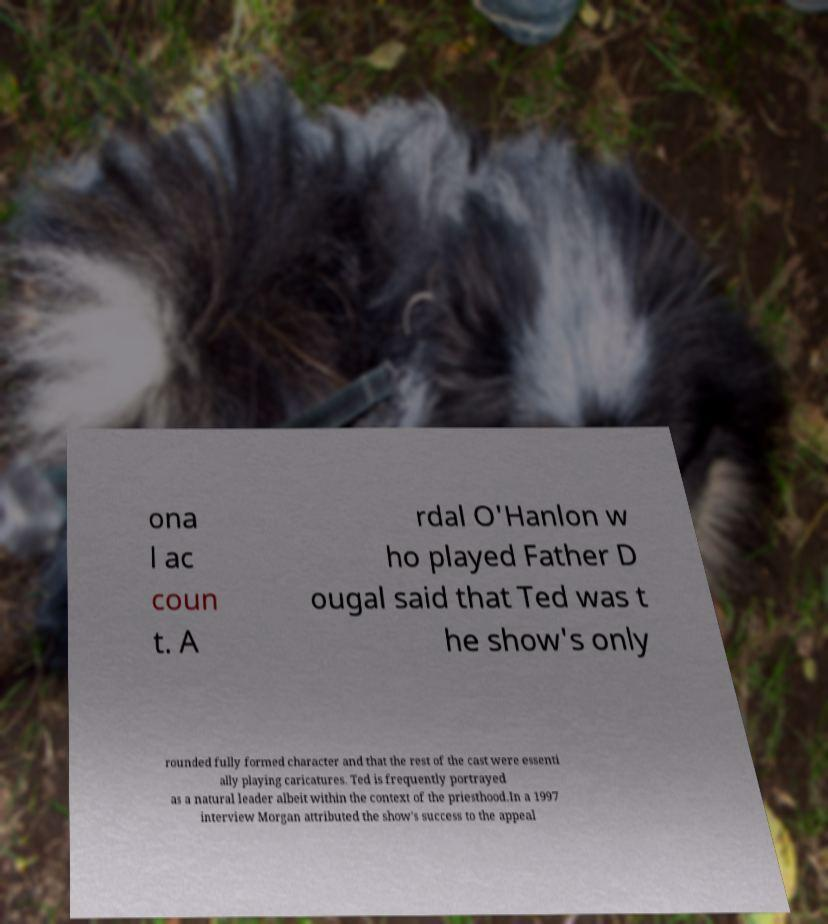Please read and relay the text visible in this image. What does it say? ona l ac coun t. A rdal O'Hanlon w ho played Father D ougal said that Ted was t he show's only rounded fully formed character and that the rest of the cast were essenti ally playing caricatures. Ted is frequently portrayed as a natural leader albeit within the context of the priesthood.In a 1997 interview Morgan attributed the show's success to the appeal 